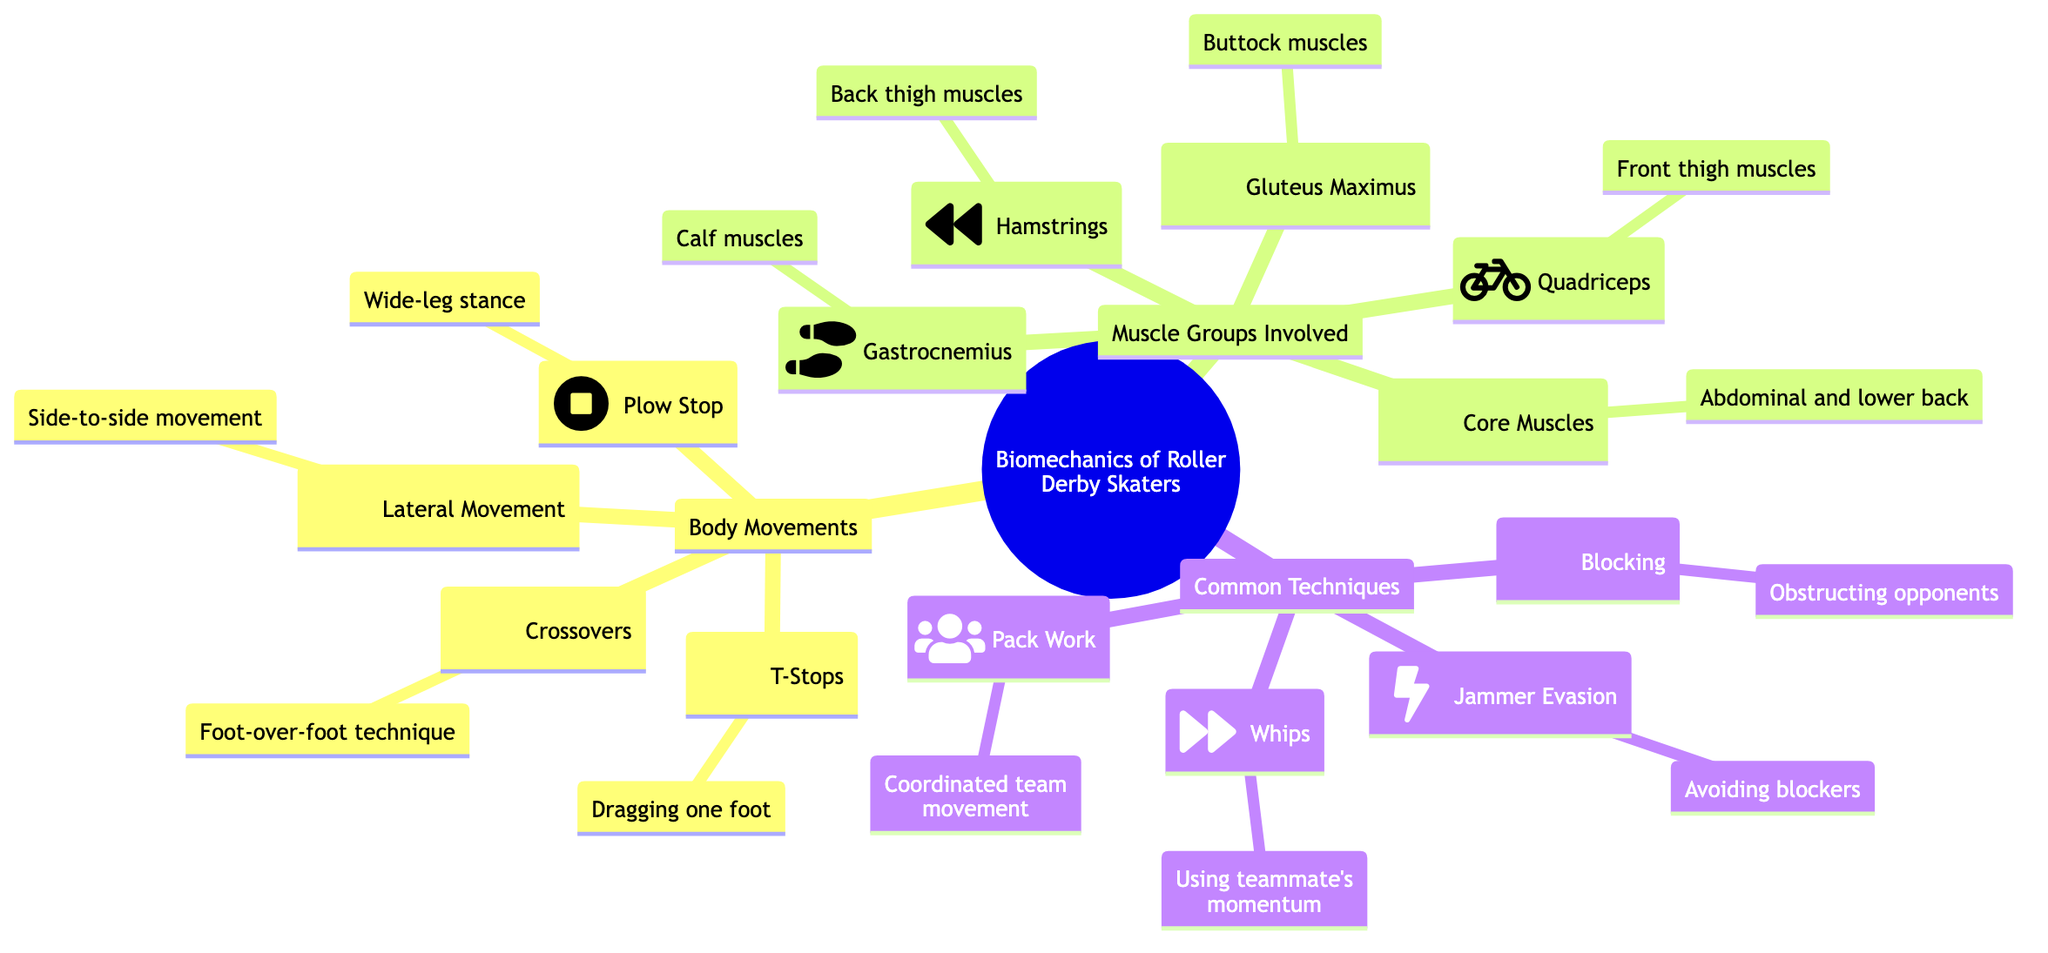What is the first body movement listed in the diagram? The diagram lists "Lateral Movement" as the first body movement under the "Body Movements" category.
Answer: Lateral Movement How many muscle groups are involved in roller derby skating? The diagram lists five muscle groups under the "Muscle Groups Involved" category, which includes Quadriceps, Hamstrings, Gluteus Maximus, Gastrocnemius, and Core Muscles.
Answer: 5 Which common technique involves avoiding blockers? The diagram specifies "Jammer Evasion" as the common technique for avoiding blockers.
Answer: Jammer Evasion What type of stop is illustrated by dragging one foot? The diagram describes this stop as a "T-Stops," indicating the technique used while dragging one foot.
Answer: T-Stops What muscle group represents the buttock muscles? The diagram identifies "Gluteus Maximus" as the muscle group that corresponds to the buttock muscles.
Answer: Gluteus Maximus How does the "Plow Stop" technique differ from "Crossovers"? "Plow Stop" involves a wide-leg stance for braking, whereas "Crossovers" involves a foot-over-foot technique for speed and maneuverability.
Answer: They serve different purposes; Plow Stop is to stop while Crossovers are for speed 